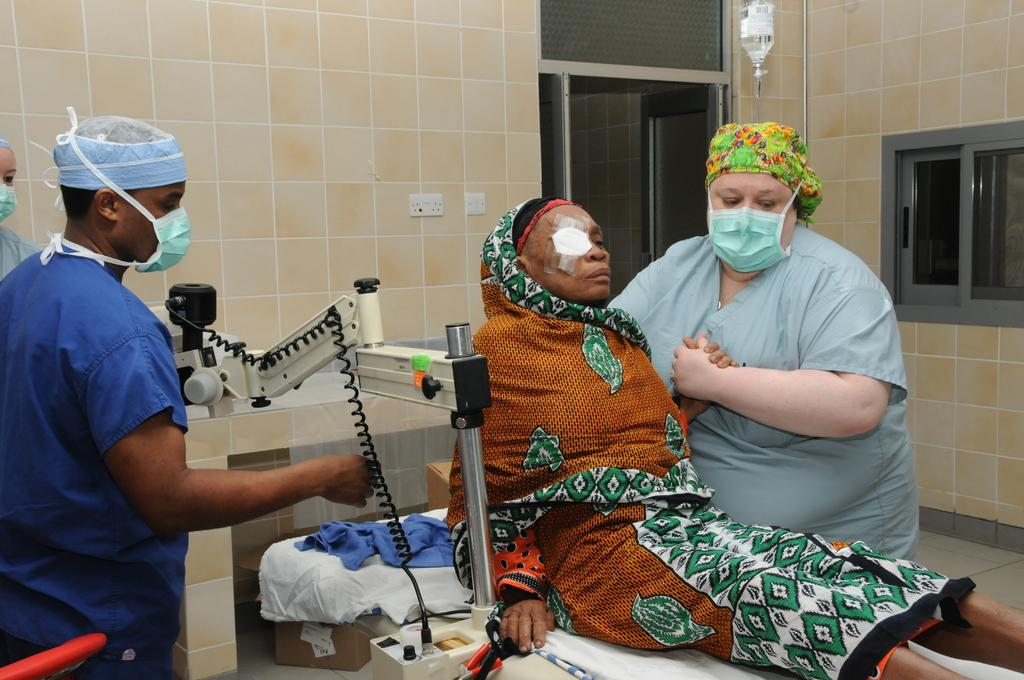What is the lady doing in the image? The lady is on the bed in the image. Are there any other people present in the image? Yes, there are other people in the image. What can be seen in the image besides the people? There is equipment visible in the image. What is visible in the background of the image? There is a window in the image. What is on the wall in the image? There are switch boards on the wall in the image. What type of throne is the lady sitting on in the image? There is no throne present in the image; the lady is on a bed. Can you see a giraffe in the image? No, there is no giraffe present in the image. 